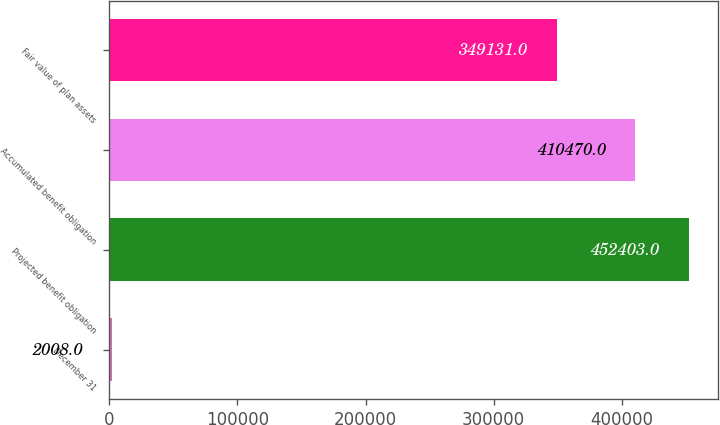Convert chart. <chart><loc_0><loc_0><loc_500><loc_500><bar_chart><fcel>December 31<fcel>Projected benefit obligation<fcel>Accumulated benefit obligation<fcel>Fair value of plan assets<nl><fcel>2008<fcel>452403<fcel>410470<fcel>349131<nl></chart> 